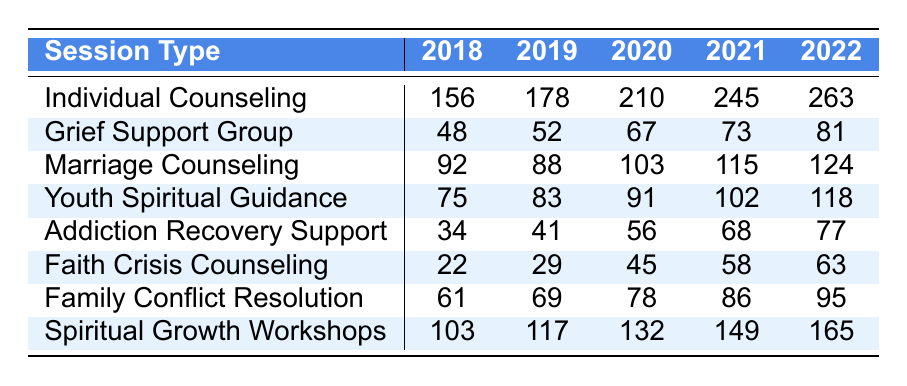What was the attendance for Individual Counseling in 2020? The table shows that the attendance for Individual Counseling in 2020 is listed as 210.
Answer: 210 How many sessions did Grief Support Group have in total from 2018 to 2022? To find the total, sum the attendances for the years: 48 + 52 + 67 + 73 + 81 = 321.
Answer: 321 Did the attendance for Marriage Counseling increase every year? Checking the data for Marriage Counseling: 92 (2018), 88 (2019), 103 (2020), 115 (2021), 124 (2022). The attendance decreased from 2018 to 2019; thus, it did not increase every year.
Answer: No Which counseling session had the highest attendance in 2022? In 2022, the attendances are: Individual Counseling (263), Grief Support Group (81), Marriage Counseling (124), Youth Spiritual Guidance (118), Addiction Recovery Support (77), Faith Crisis Counseling (63), Family Conflict Resolution (95), Spiritual Growth Workshops (165). Individual Counseling had the highest attendance at 263.
Answer: Individual Counseling What is the average attendance for Youth Spiritual Guidance over the five years? The attendances are 75, 83, 91, 102, and 118. Sum them: 75 + 83 + 91 + 102 + 118 = 469. There are 5 years, so average = 469 / 5 = 93.8.
Answer: 93.8 Which session had the smallest growth in attendance from 2018 to 2022? Calculate the growth for each session from 2018 to 2022. Individual Counseling: 263 - 156 = 107. Grief Support Group: 81 - 48 = 33. Marriage Counseling: 124 - 92 = 32. Youth Spiritual Guidance: 118 - 75 = 43. Addiction Recovery Support: 77 - 34 = 43. Faith Crisis Counseling: 63 - 22 = 41. Family Conflict Resolution: 95 - 61 = 34. Spiritual Growth Workshops: 165 - 103 = 62. The smallest growth is Marriage Counseling with 32.
Answer: Marriage Counseling What percentage increase in attendance did Addiction Recovery Support see from 2018 to 2022? The attendance in 2018 was 34 and in 2022 was 77. The increase is 77 - 34 = 43. To find the percentage increase: (43 / 34) * 100 = 126.47%.
Answer: 126.47% Between which two years did Family Conflict Resolution see the largest increase in attendance? The attendances are: 61 (2018), 69 (2019), 78 (2020), 86 (2021), 95 (2022). The increases are: 69 - 61 = 8, 78 - 69 = 9, 86 - 78 = 8, 95 - 86 = 9. The largest increase is between 2019 and 2020 with an increase of 9.
Answer: 2019 to 2020 